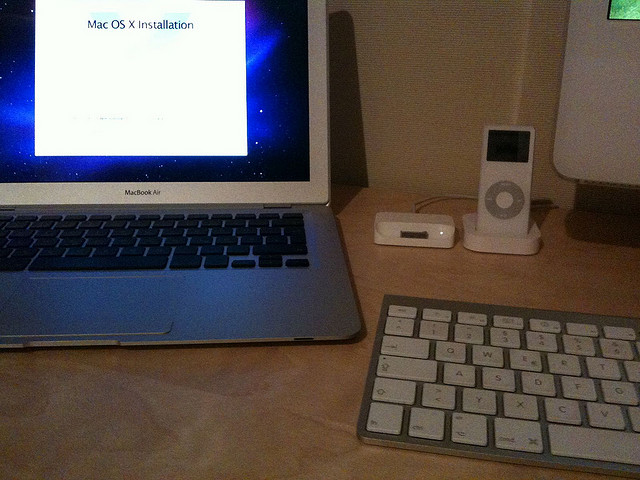<image>How much money does this person make when working with this computer? It's impossible to know how much money this person makes when working with this computer. How much money does this person make when working with this computer? It is unanswerable how much money this person makes when working with this computer. 